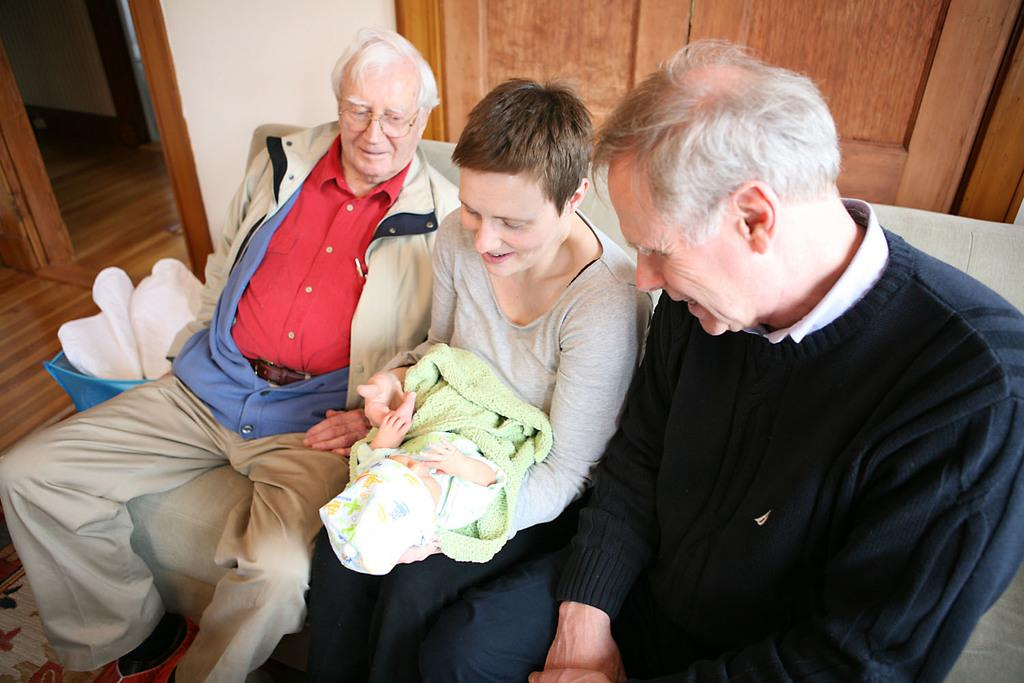What is the woman in the image doing? The woman is sitting on a sofa and holding a baby. Who else is present in the image? There are two old men sitting beside the woman. What can be seen at the top of the image? There appears to be a door at the top of the image. How many beads are on the baby's necklace in the image? There is no baby's necklace visible in the image, so it is not possible to determine the number of beads. 